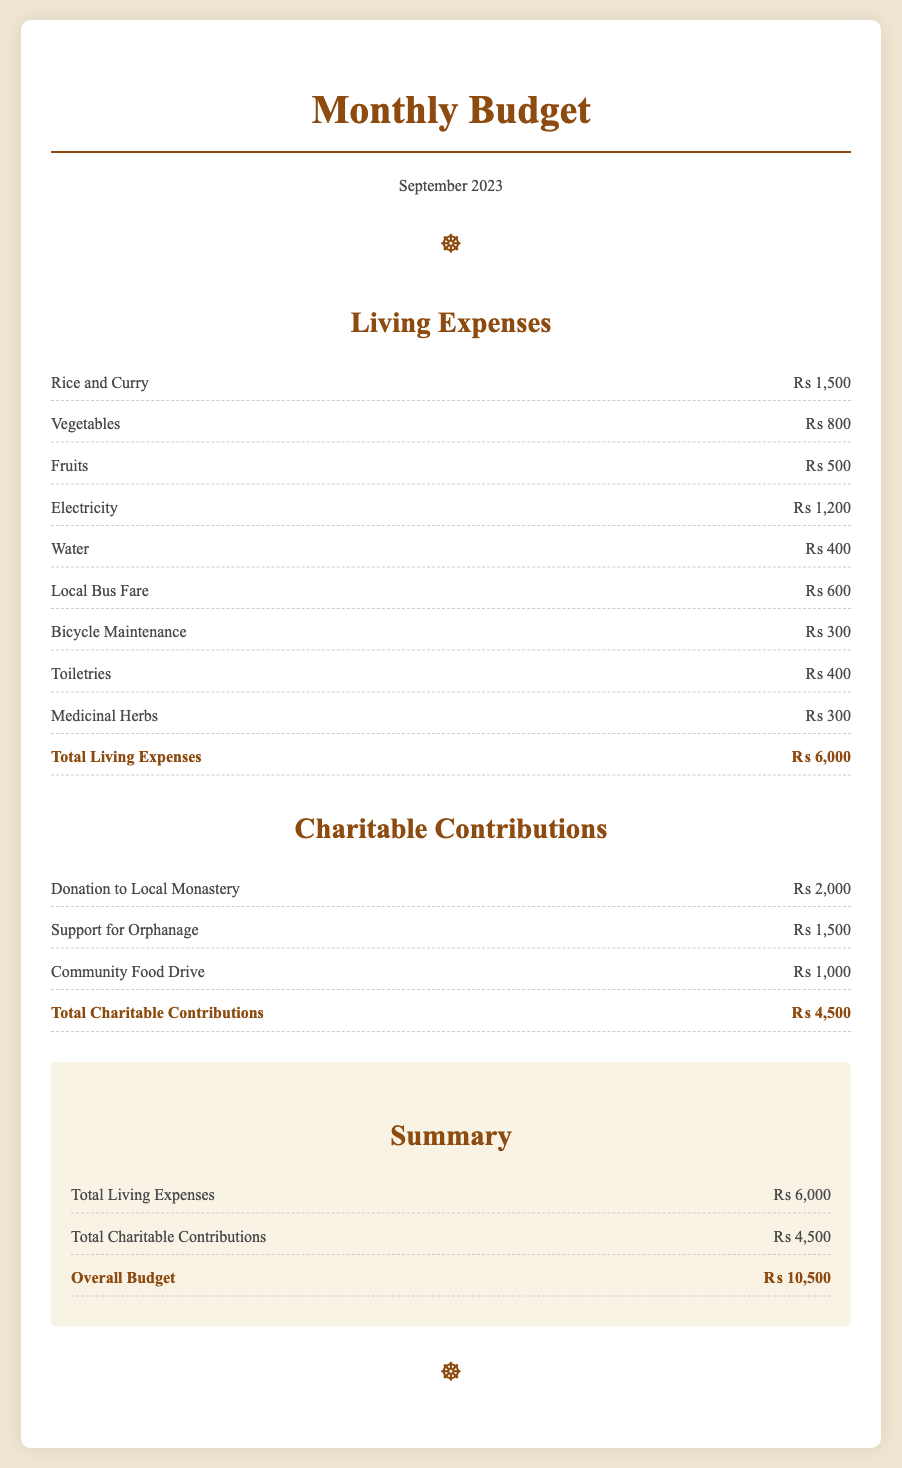What are the total living expenses for September 2023? The total living expenses are listed in the document under living expenses, which adds up to ₨ 6,000.
Answer: ₨ 6,000 How much was donated to the local monastery? The document specifies the donation amount to the local monastery as part of charitable contributions.
Answer: ₨ 2,000 What is the expense for electricity? The document mentions the specific cost for electricity within the living expenses section.
Answer: ₨ 1,200 What was spent on fruits? The amount spent on fruits is explicitly stated in the living expenses section.
Answer: ₨ 500 What is the total for charitable contributions? The document provides the total amount allocated for charitable contributions, summarizing it at the end.
Answer: ₨ 4,500 How much is spent on bicycle maintenance? The specific expense for bicycle maintenance is detailed in the living expenses section of the document.
Answer: ₨ 300 What is the overall budget for the month? The overall budget is calculated at the end of the document, summing both living expenses and charitable contributions.
Answer: ₨ 10,500 How much is allocated for community food drive? The document states the amount contributed to the community food drive within the charitable contributions section.
Answer: ₨ 1,000 What are the total expenses for September 2023? The total expenses can be inferred by combining both living expenses and charitable contributions as shown in the document.
Answer: ₨ 10,500 